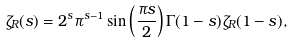<formula> <loc_0><loc_0><loc_500><loc_500>\zeta _ { R } ( s ) = 2 ^ { s } \pi ^ { s - 1 } \sin \left ( \frac { \pi s } { 2 } \right ) \Gamma ( 1 - s ) \zeta _ { R } ( 1 - s ) ,</formula> 